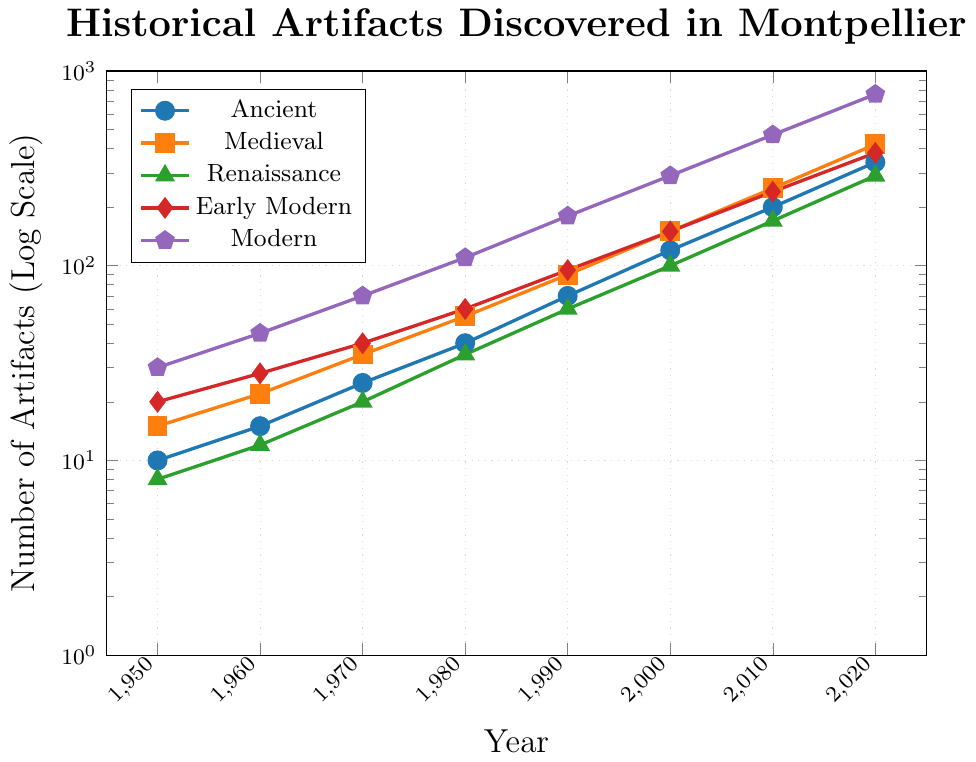Which era exhibited the highest number of artifacts discovered in 2020? By inspecting the endpoints of the lines in the log scale graph for the year 2020, we observe that the Modern era has the highest marker at around 760 artifacts.
Answer: Modern How did the number of Ancient artifacts discovered change from 1950 to 2020? In 1950, there were 10 Ancient artifacts discovered, and by 2020, this number increased to 340. The change is calculated as 340 - 10.
Answer: 330 Comparing the Medieval and Renaissance eras, which era had more artifacts discovered in 1980, and by how much? Reading the data points for 1980, Medieval had 55 artifacts, and Renaissance had 35. The difference is 55 - 35.
Answer: Medieval, 20 What's the average number of artifacts discovered in 2000 for all eras combined? Sum the artifacts from all eras in 2000 (120 + 150 + 100 + 150 + 290) and divide by the number of eras (5). The sum is 810. Average is 810 / 5.
Answer: 162 By how many artifacts did the number of Early Modern artifacts increase from 1970 to 1990? In 1970, 40 Early Modern artifacts were discovered; in 1990, 95 were discovered. The increase is calculated as 95 - 40.
Answer: 55 Which era had the least number of artifacts discovered in 1960? Comparing the numbers in 1960, the Renaissance era had the least with 12 artifacts discovered.
Answer: Renaissance What is the total number of artifacts discovered in 2010 across all eras? Sum the artifacts discovered in each era in 2010 (200 + 250 + 170 + 240 + 470). The total sum is 1330.
Answer: 1330 What is the trend in the number of Medieval artifacts discovered from 1950 to 2020? The graph shows a consistently increasing trend in the number of Medieval artifacts discovered, starting from 15 in 1950 to 420 in 2020.
Answer: Increasing Between which decades did the number of Modern artifacts see the highest increase? Observing the differences in the number of Modern artifacts discovered in each decade, the highest increase occurred between 2010 (470) and 2020 (760). The increase is 760 - 470.
Answer: 2010 to 2020 Which era showed the least increase in artifacts from 2000 to 2010? Calculate the differences: Ancient (200 - 120 = 80), Medieval (250 - 150 = 100), Renaissance (170 - 100 = 70), Early Modern (240 - 150 = 90), Modern (470 - 290 = 180). The Renaissance era showed the least increase of 70 artifacts.
Answer: Renaissance 